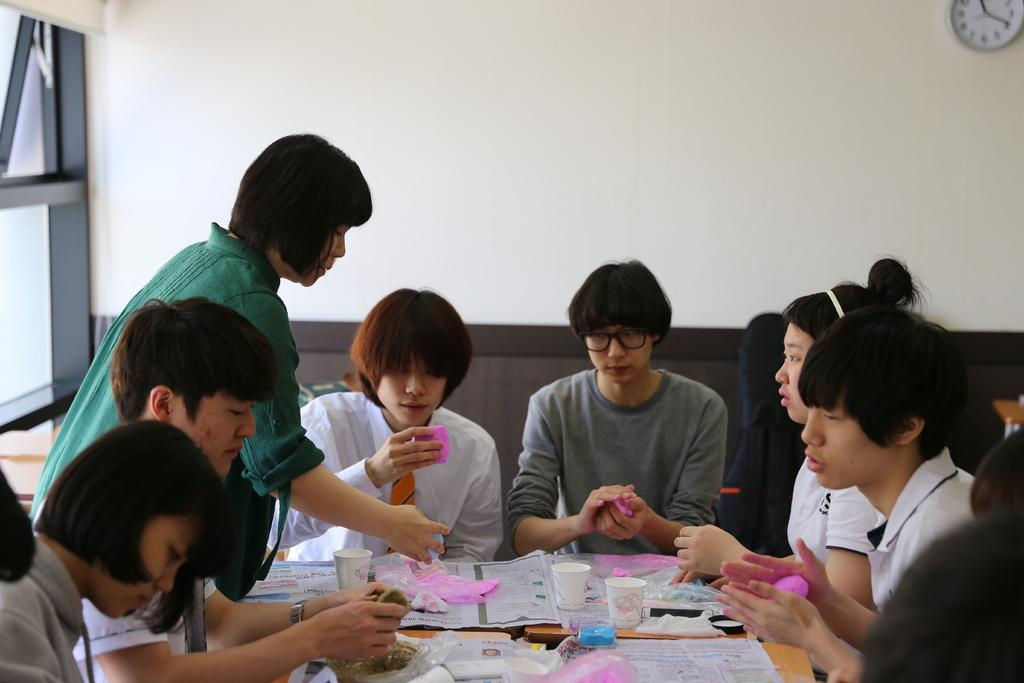What are the persons in the image doing? The persons in the image are sitting on chairs around a table. What objects can be seen on the table? There are papers, cups, and bottles on the table. What is visible in the background of the image? There is a wall and a clock in the background. What grade did the person sitting at the table receive on their prose writing? There is no information about a person receiving a grade on their prose writing in the image. 